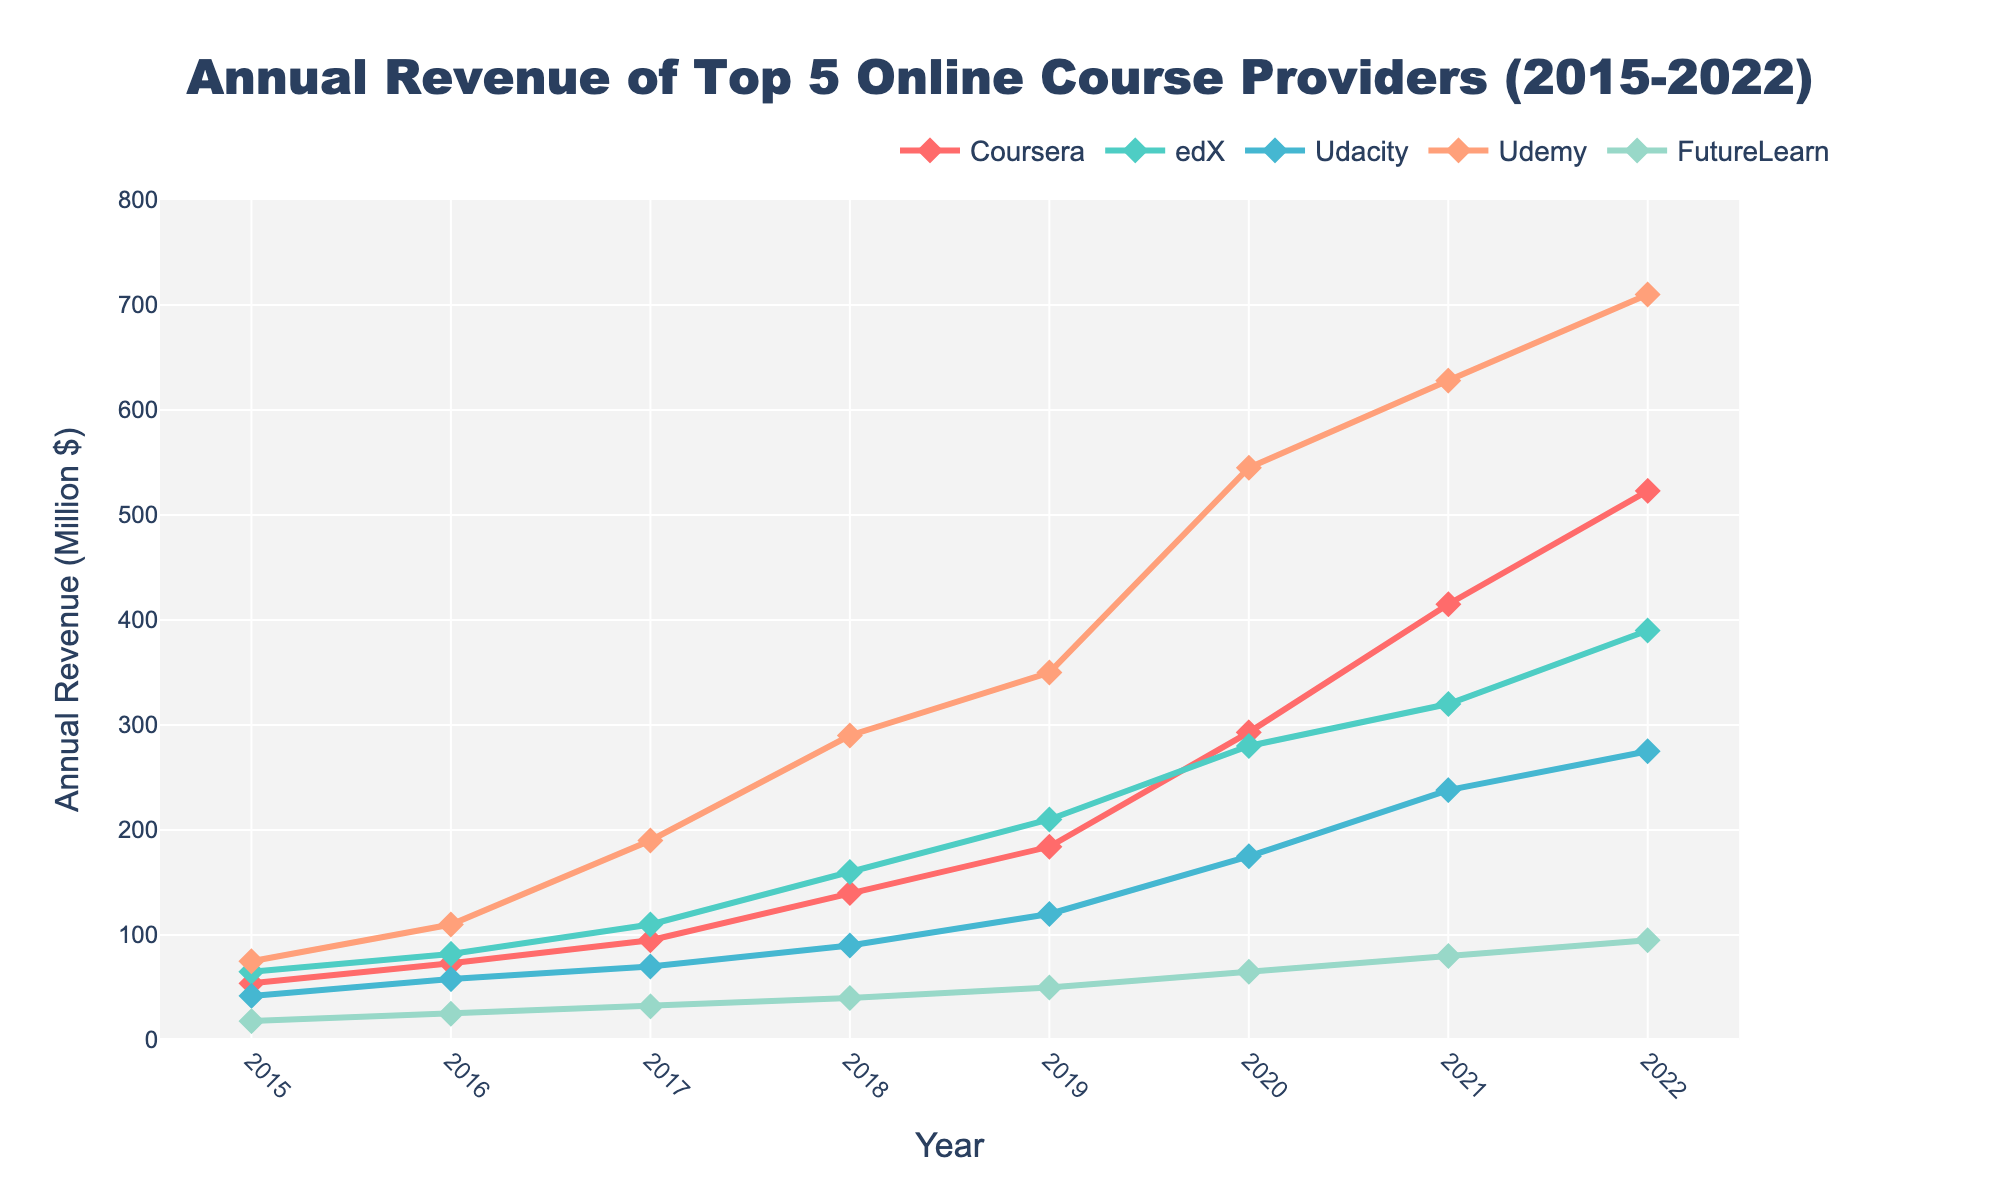What is the trend in Udemy’s annual revenue from 2015 to 2022? Udemy’s annual revenue shows a consistently increasing trend from 75 million dollars in 2015 to 710 million dollars in 2022.
Answer: Increasing Which provider had the highest revenue in 2022? In 2022, Udemy had the highest revenue among the top 5 online course providers, reaching 710 million dollars.
Answer: Udemy How much did Coursera’s annual revenue increase from 2015 to 2022? In 2015, Coursera’s revenue was 54 million dollars, and it increased to 523 million dollars in 2022. The increase in revenue is 523 - 54 = 469 million dollars.
Answer: 469 million dollars Which year did FutureLearn first reach 50 million dollars in annual revenue? In 2019, FutureLearn's annual revenue was 50 million dollars, marking the first year it reached that amount.
Answer: 2019 Compare the revenue growth of Coursera and edX between 2015 and 2022. Coursera's revenue grew from 54 million in 2015 to 523 million in 2022, an increase of 523 - 54 = 469 million. edX's revenue grew from 65 million in 2015 to 390 million in 2022, an increase of 390 - 65 = 325 million. Thus, Coursera's growth was 469 million, and edX's growth was 325 million.
Answer: Coursera: 469 million, edX: 325 million Between which years did Udacity experience its highest annual revenue increase? Udacity experienced its highest annual revenue increase between 2019 and 2020, increasing from 120 million dollars in 2019 to 175 million dollars in 2020. The increase is 175 - 120 = 55 million dollars.
Answer: Between 2019 and 2020 By how much did the combined revenue of all five providers increase from 2020 to 2021? The combined revenue in 2020 was 293 (Coursera) + 280 (edX) + 175 (Udacity) + 545 (Udemy) + 65 (FutureLearn) = 1358 million dollars. In 2021, it was 415 (Coursera) + 320 (edX) + 238 (Udacity) + 628 (Udemy) + 80 (FutureLearn) = 1681 million dollars. The increase is 1681 - 1358 = 323 million dollars.
Answer: 323 million dollars Which provider had the smallest revenue in 2016, and what was it? In 2016, FutureLearn had the smallest revenue among the providers, with a revenue of 25 million dollars.
Answer: FutureLearn, 25 million dollars 